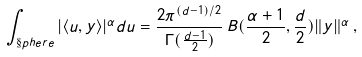<formula> <loc_0><loc_0><loc_500><loc_500>\int _ { \S p h e r e } | \langle u , y \rangle | ^ { \alpha } d u = \frac { 2 \pi ^ { ( d - 1 ) / 2 } } { \Gamma ( \frac { d - 1 } { 2 } ) } \, B ( \frac { \alpha + 1 } { 2 } , \frac { d } { 2 } ) \| y \| ^ { \alpha } \, ,</formula> 